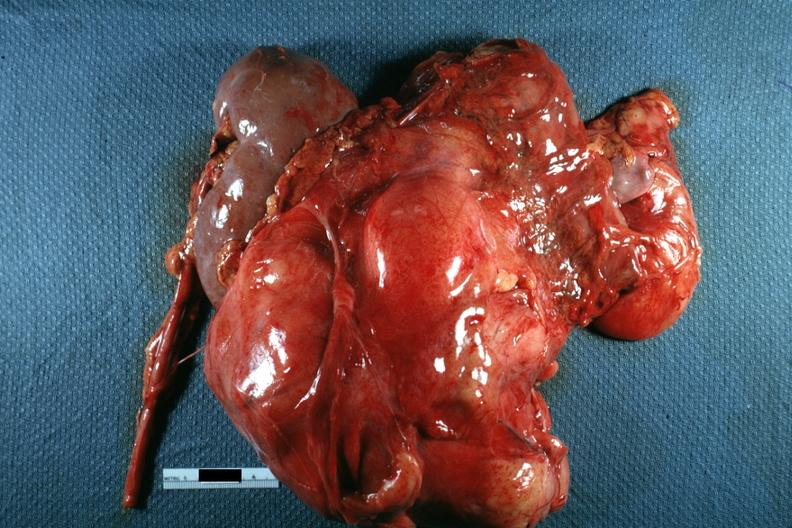s retroperitoneal liposarcoma present?
Answer the question using a single word or phrase. Yes 